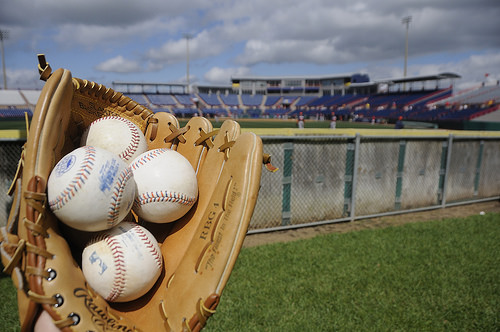<image>
Can you confirm if the glove is in front of the fence? Yes. The glove is positioned in front of the fence, appearing closer to the camera viewpoint. 